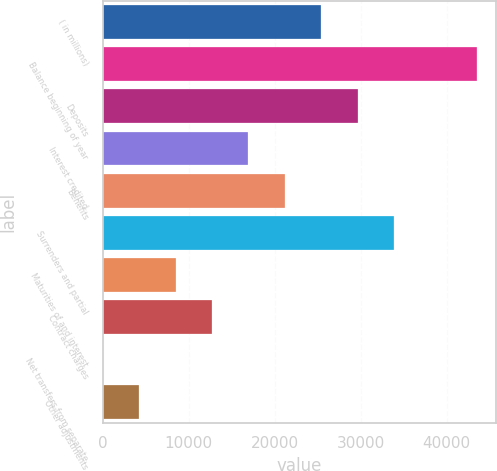<chart> <loc_0><loc_0><loc_500><loc_500><bar_chart><fcel>( in millions)<fcel>Balance beginning of year<fcel>Deposits<fcel>Interest credited<fcel>Benefits<fcel>Surrenders and partial<fcel>Maturities of and interest<fcel>Contract charges<fcel>Net transfers from separate<fcel>Other adjustments<nl><fcel>25403.6<fcel>43551.1<fcel>29635.7<fcel>16939.4<fcel>21171.5<fcel>33867.8<fcel>8475.2<fcel>12707.3<fcel>11<fcel>4243.1<nl></chart> 